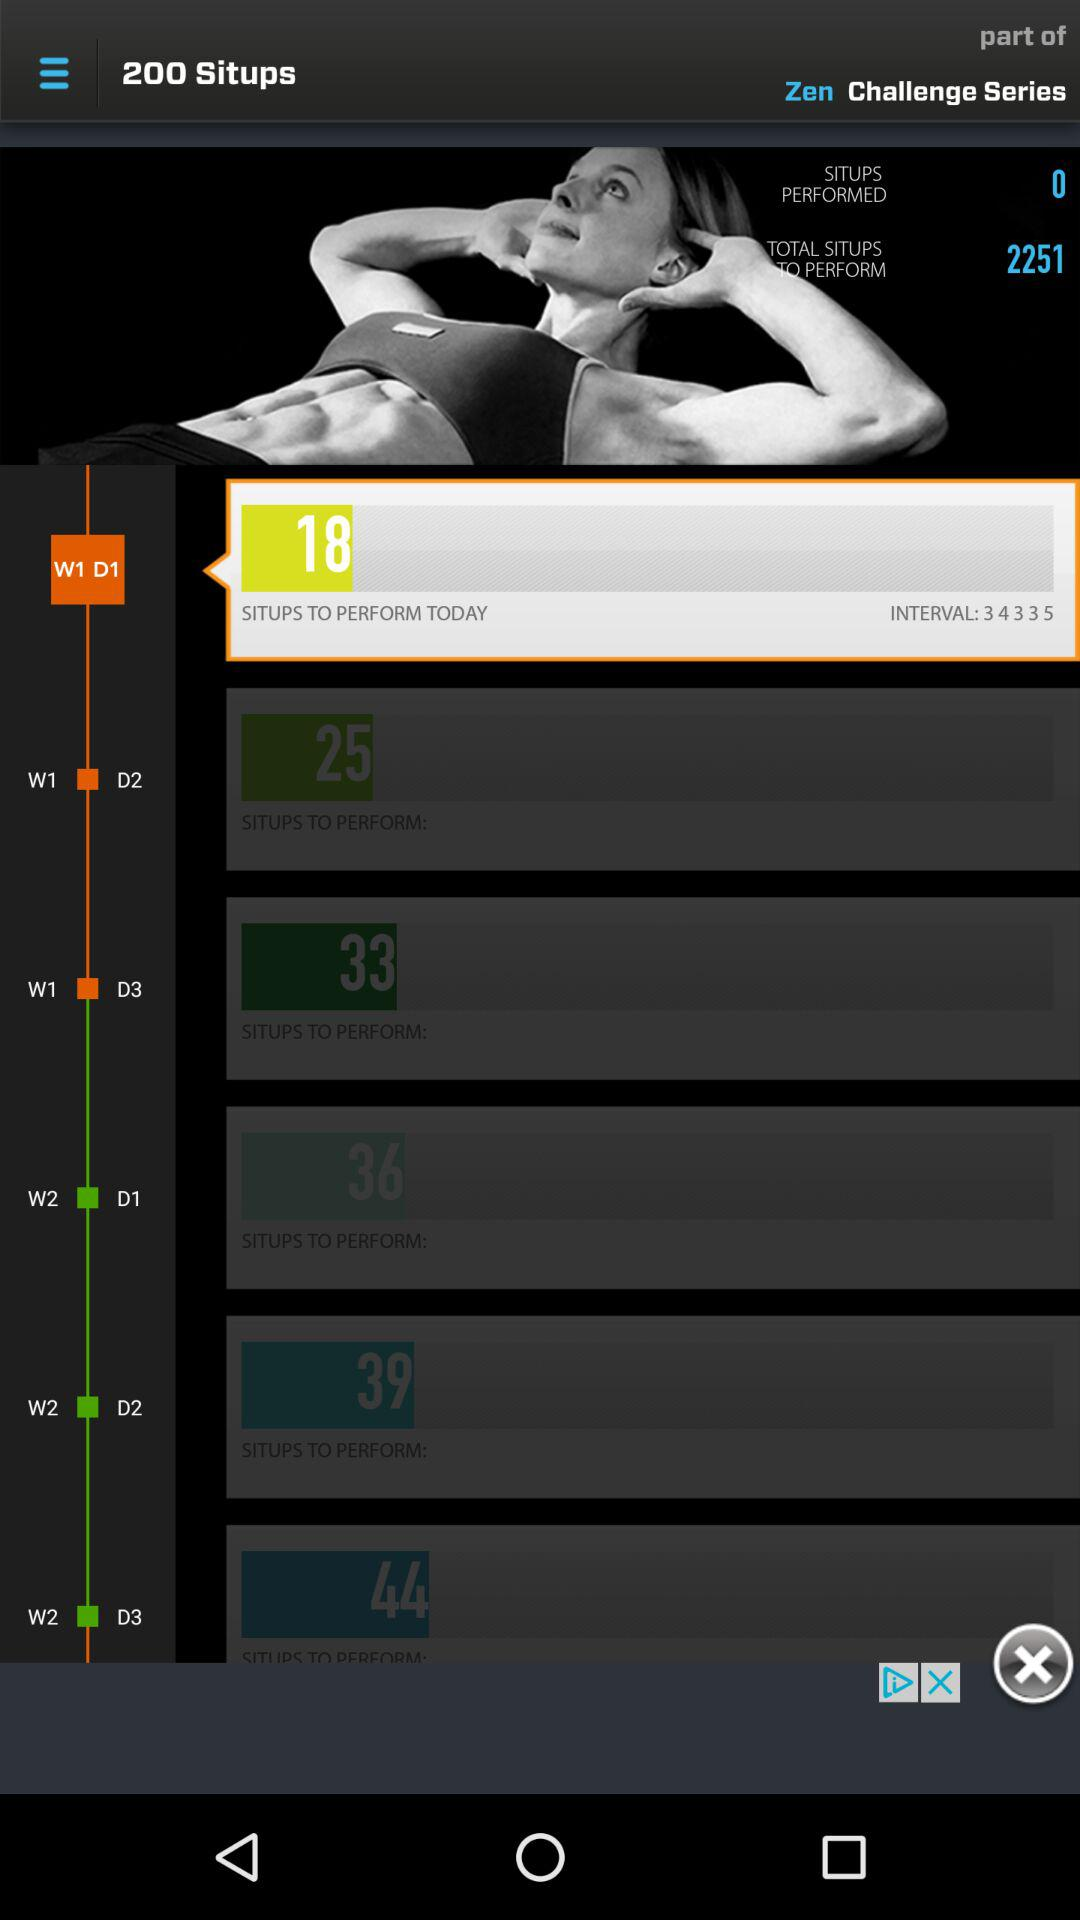How many calories do the sit-ups burn?
When the provided information is insufficient, respond with <no answer>. <no answer> 